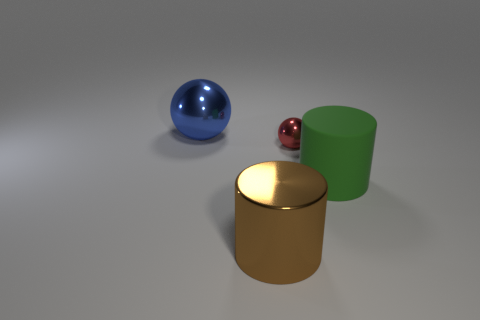Is the number of big shiny cylinders that are to the right of the big rubber thing the same as the number of brown metallic things that are to the right of the red ball? yes 